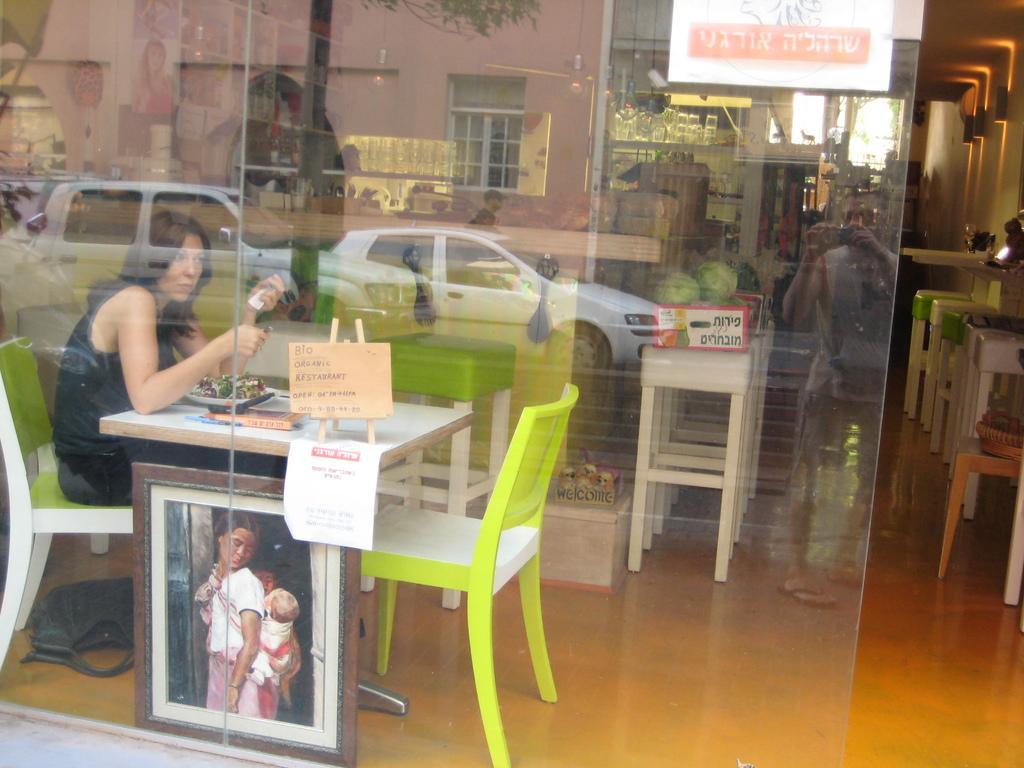In one or two sentences, can you explain what this image depicts? In this picture we can see woman sitting on chair holding paper in her hands and in front of her on table we have plate with some food item, board and under table we have a photo frame and in background we can see cars on road, building with windows, trees as a reflection. 